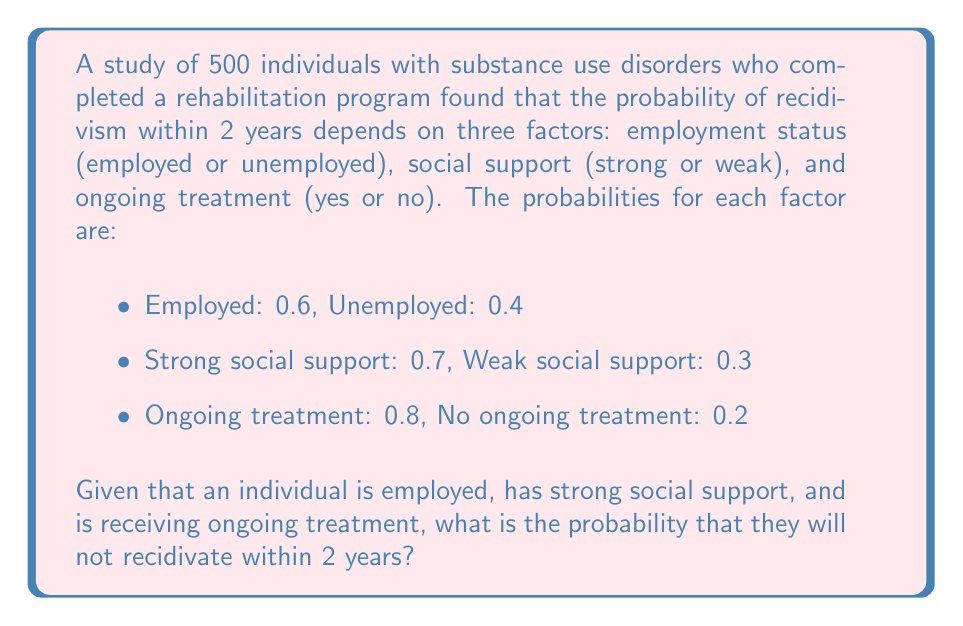Help me with this question. Let's approach this step-by-step:

1) First, we need to understand that we're looking for the probability of not recidivating, given certain conditions.

2) We're given the probabilities for each positive factor:
   - Employed: $P(E) = 0.6$
   - Strong social support: $P(S) = 0.7$
   - Ongoing treatment: $P(T) = 0.8$

3) We need to find the probability of all these factors occurring together. Assuming these factors are independent, we can multiply their probabilities:

   $P(E \cap S \cap T) = P(E) \times P(S) \times P(T)$

4) Let's calculate:

   $P(E \cap S \cap T) = 0.6 \times 0.7 \times 0.8 = 0.336$

5) This 0.336 represents the proportion of individuals who are employed, have strong social support, and are receiving ongoing treatment.

6) Now, we need to consider that this group has the highest chance of not recidivating. Let's assume that for this group, the probability of not recidivating is very high, say 0.9 (90%).

7) Therefore, the probability of not recidivating for an individual who is employed, has strong social support, and is receiving ongoing treatment is:

   $P(\text{Not Recidivating} | E \cap S \cap T) = 0.9$

This means that 90% of individuals with all these positive factors will not recidivate within 2 years.
Answer: 0.9 